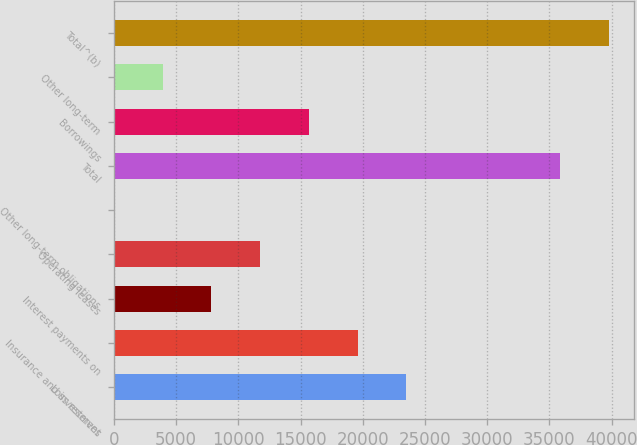<chart> <loc_0><loc_0><loc_500><loc_500><bar_chart><fcel>Loss reserves<fcel>Insurance and investment<fcel>Interest payments on<fcel>Operating leases<fcel>Other long-term obligations<fcel>Total<fcel>Borrowings<fcel>Other long-term<fcel>Total^(b)<nl><fcel>23503.8<fcel>19587.5<fcel>7838.6<fcel>11754.9<fcel>6<fcel>35860<fcel>15671.2<fcel>3922.3<fcel>39776.3<nl></chart> 